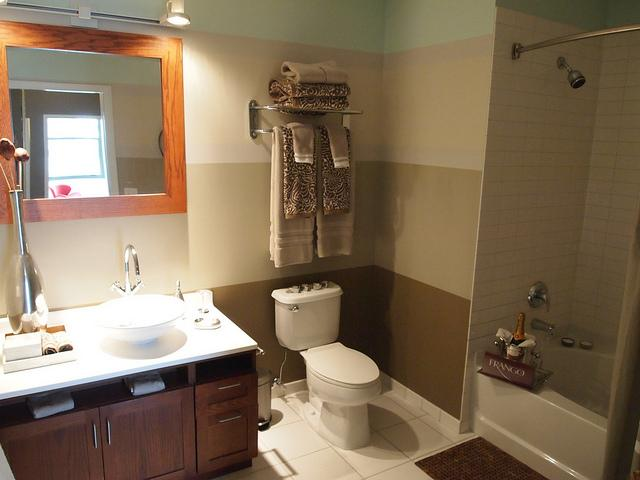What color is the border around the edges of the mirror?

Choices:
A) blue
B) wood
C) black
D) green wood 